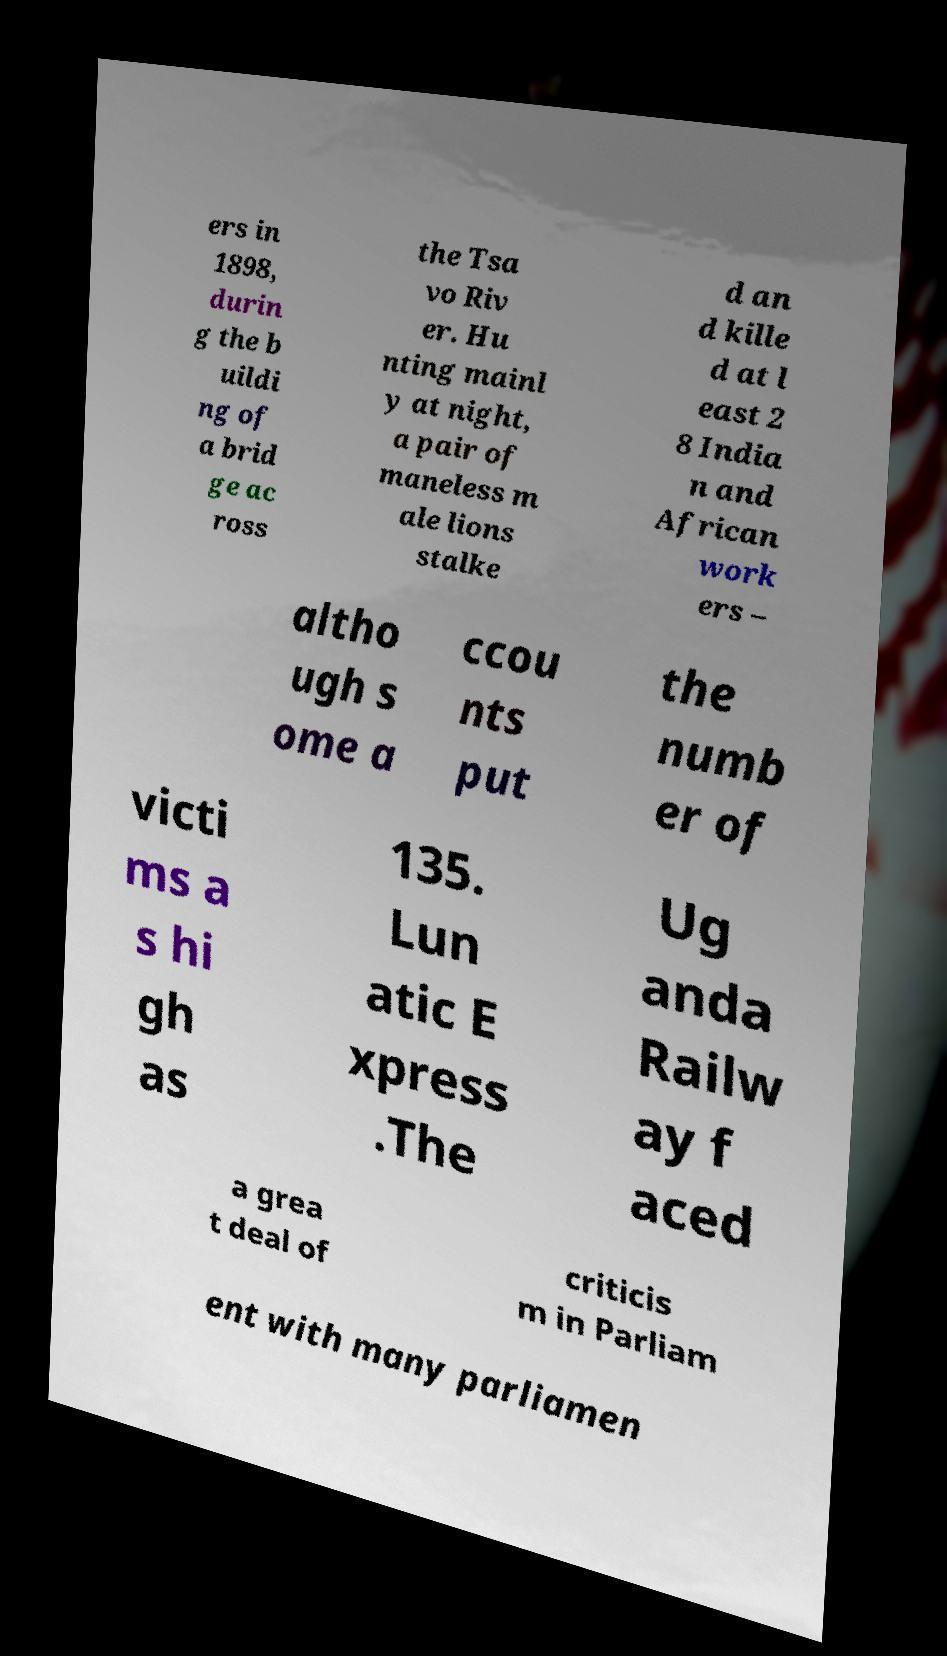Can you accurately transcribe the text from the provided image for me? ers in 1898, durin g the b uildi ng of a brid ge ac ross the Tsa vo Riv er. Hu nting mainl y at night, a pair of maneless m ale lions stalke d an d kille d at l east 2 8 India n and African work ers – altho ugh s ome a ccou nts put the numb er of victi ms a s hi gh as 135. Lun atic E xpress .The Ug anda Railw ay f aced a grea t deal of criticis m in Parliam ent with many parliamen 